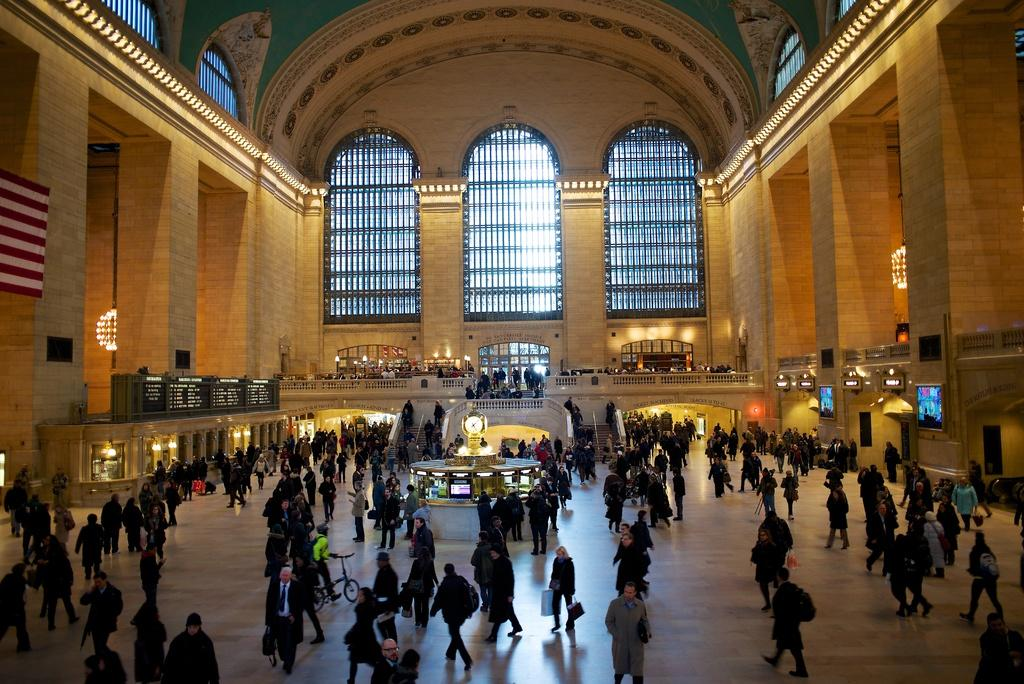What type of location is depicted in the image? The image shows an inside view of a building. Can you describe the people in the image? Yes, there are people in the image. What part of the building can be seen in the image? The floor is visible in the image. What lighting is present in the image? Lights are present in the image. What architectural features are visible in the image? Pillars, railings, and steps are visible in the image. What type of material is present in the image? Cloth is present in the image. What electronic devices are visible in the image? Screens are visible in the image. What mode of transportation is present in the image? A bicycle is present in the image. Are there any other objects visible in the image? Yes, other objects are visible in the image. What type of credit can be seen being given to the people in the image? There is no credit being given to the people in the image. What story is being told by the people in the image? There is no story being told by the people in the image. Can you describe the wings of the people in the image? There are no wings present on the people in the image. 